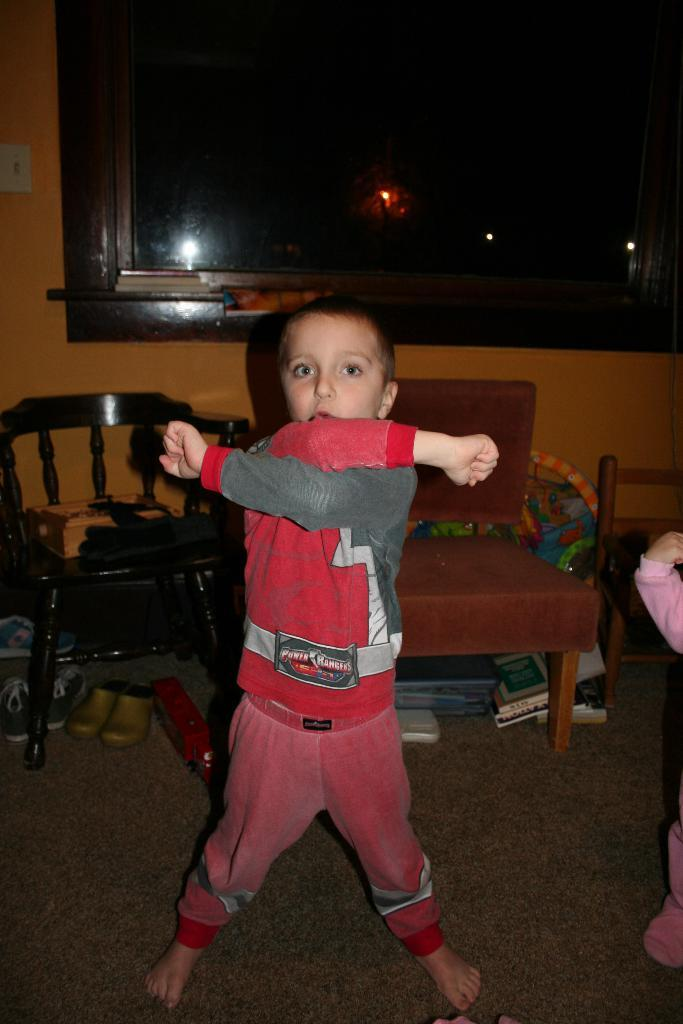Who is the main subject in the image? There is a boy in the image. What is the boy doing in the image? The boy is posing for a picture. What can be seen in the background of the image? There are chairs and a window in the background of the image. How many bikes are visible in the image? There are no bikes visible in the image. What type of stretch can be seen in the image? There is no stretch present in the image. 